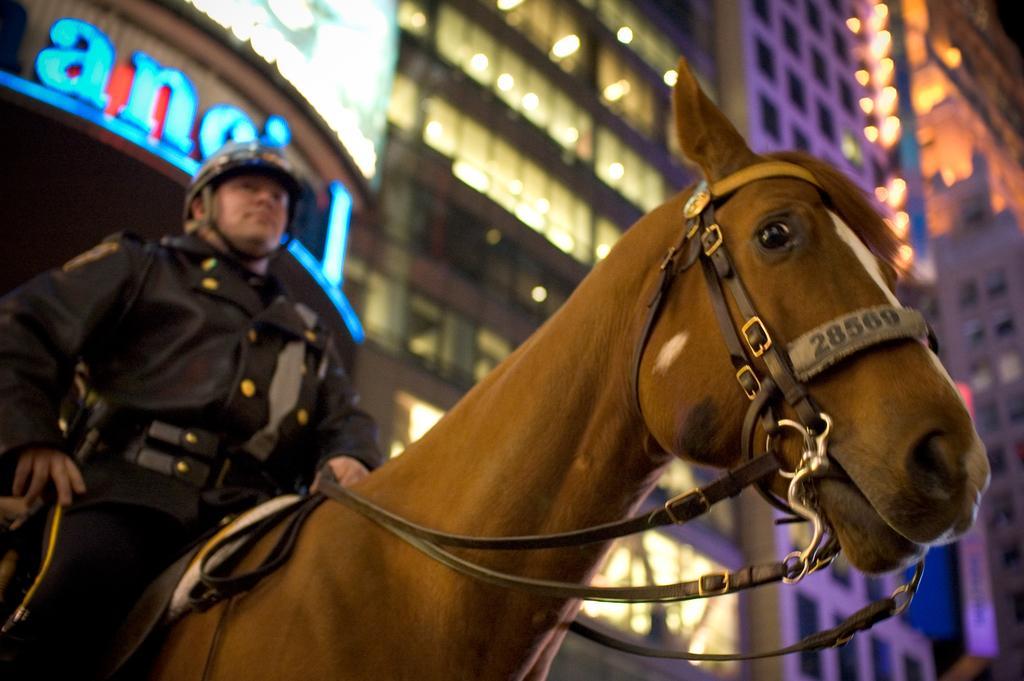Please provide a concise description of this image. This picture is of outside. In the center we can see a horse and a man sitting on the horse, wearing a helmet. In the background we can see the buildings and lights. 